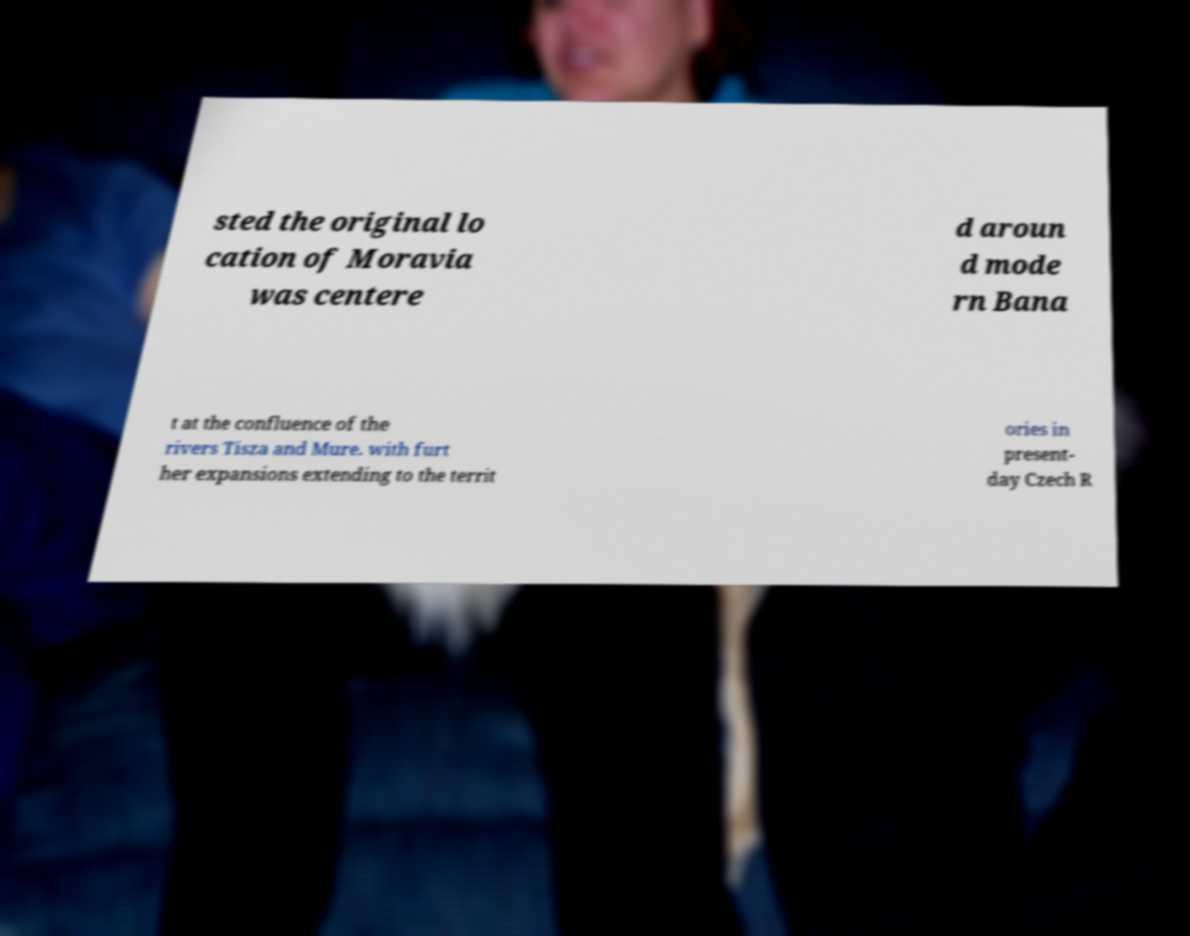Can you read and provide the text displayed in the image?This photo seems to have some interesting text. Can you extract and type it out for me? sted the original lo cation of Moravia was centere d aroun d mode rn Bana t at the confluence of the rivers Tisza and Mure. with furt her expansions extending to the territ ories in present- day Czech R 